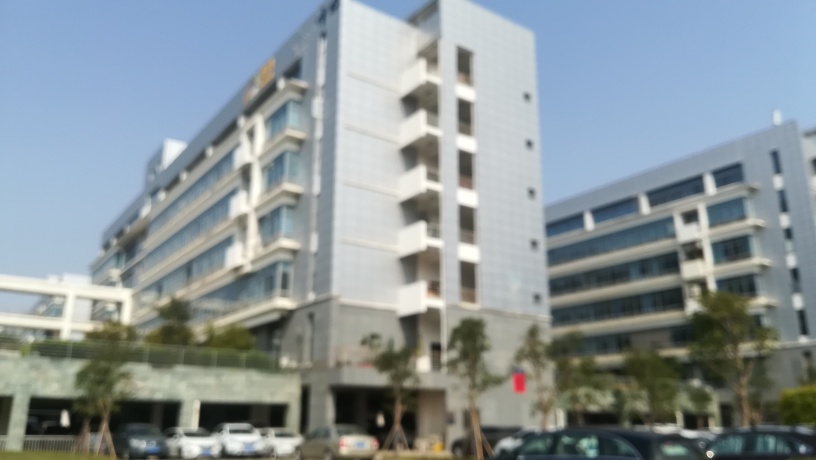Can you describe the building in this image? The building appears to be a contemporary, multi-storied structure with a combination of what seems like residential and commercial spaces. It has balconies, and below there is a covered parking area. 